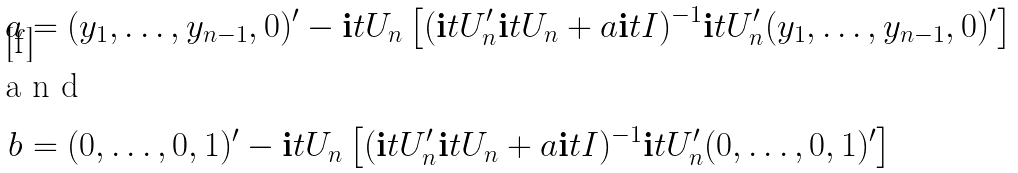Convert formula to latex. <formula><loc_0><loc_0><loc_500><loc_500>a & = ( y _ { 1 } , \dots , y _ { n - 1 } , 0 ) ^ { \prime } - \mathbf i t { U } _ { n } \left [ ( \mathbf i t { U } ^ { \prime } _ { n } \mathbf i t { U } _ { n } + a \mathbf i t { I } ) ^ { - 1 } \mathbf i t { U } _ { n } ^ { \prime } ( y _ { 1 } , \dots , y _ { n - 1 } , 0 ) ^ { \prime } \right ] \\ \intertext { a n d } b & = ( 0 , \dots , 0 , 1 ) ^ { \prime } - \mathbf i t { U } _ { n } \left [ ( \mathbf i t { U } ^ { \prime } _ { n } \mathbf i t { U } _ { n } + a \mathbf i t { I } ) ^ { - 1 } \mathbf i t { U } _ { n } ^ { \prime } ( 0 , \dots , 0 , 1 ) ^ { \prime } \right ]</formula> 